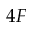<formula> <loc_0><loc_0><loc_500><loc_500>4 F</formula> 